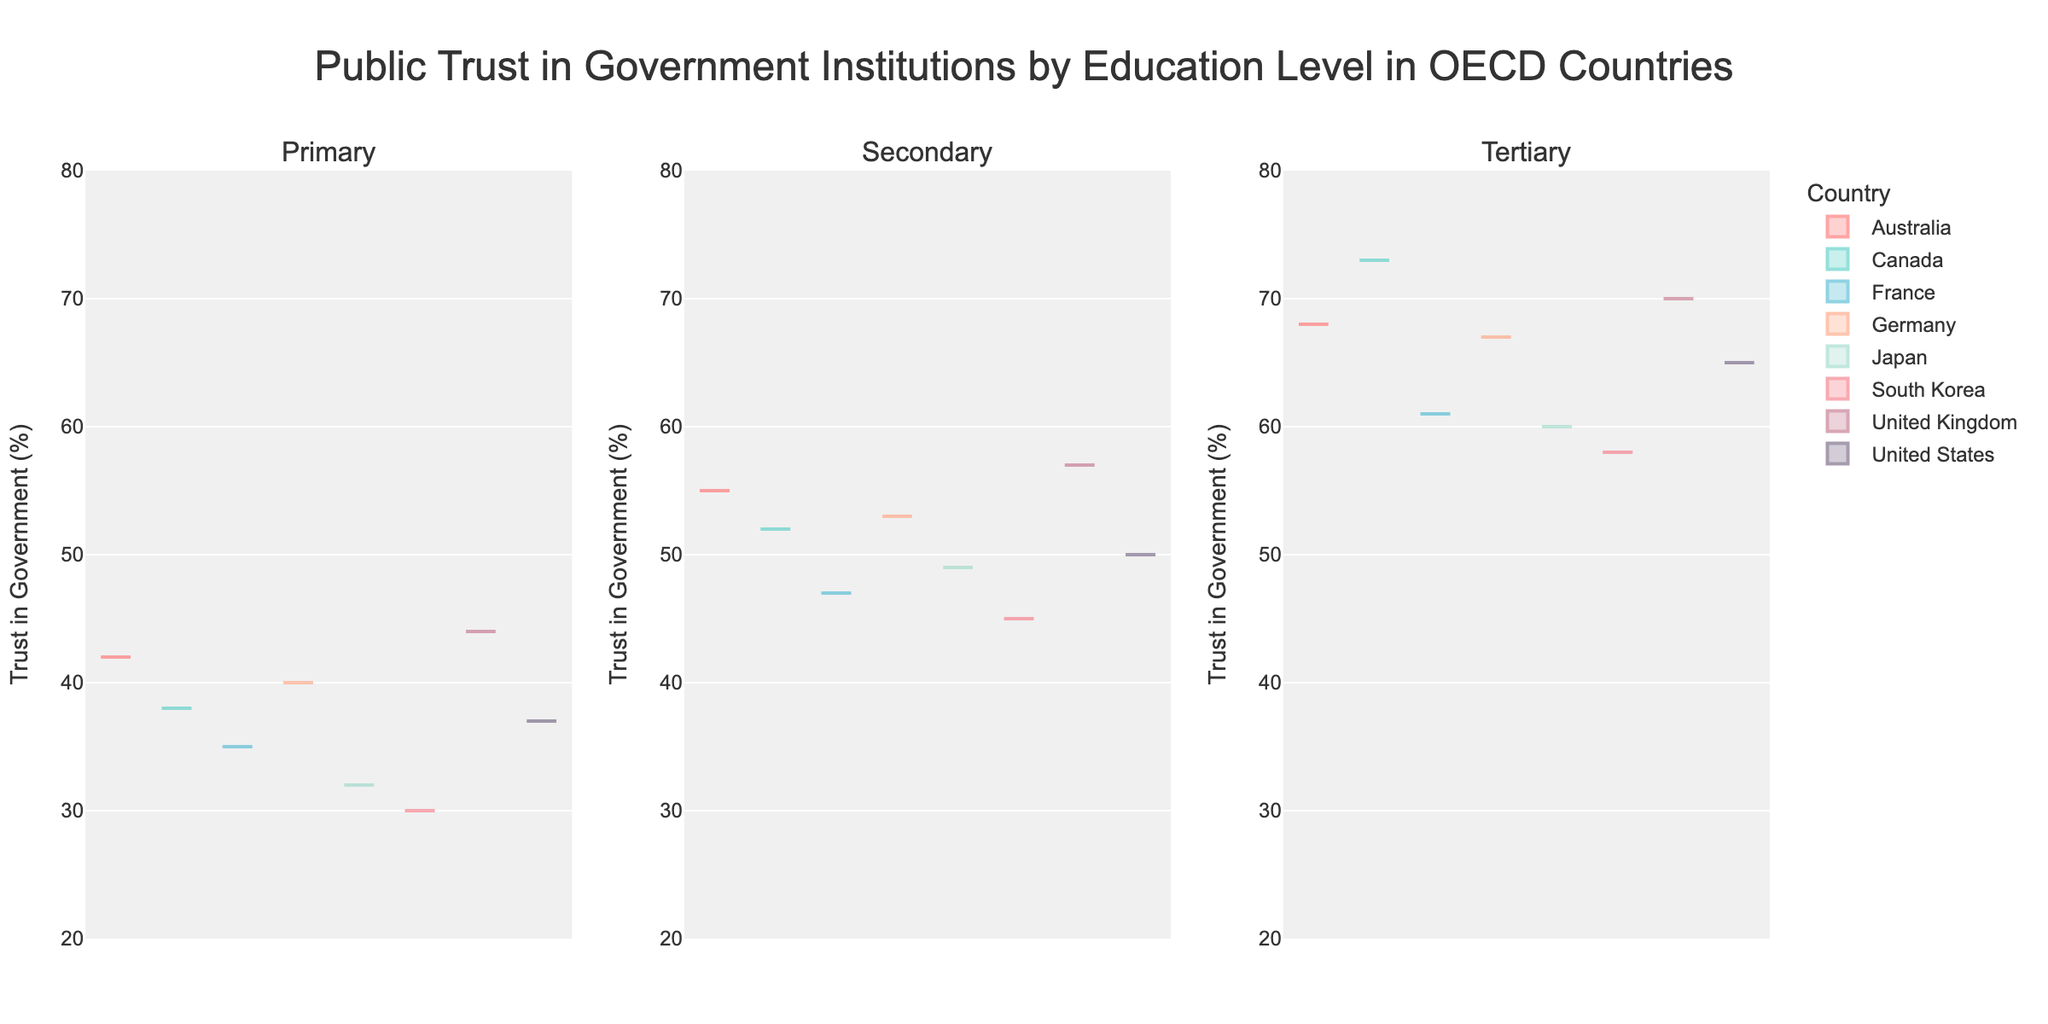what is the title of the plot? The title is placed at the top center of the plot, which is a standard location for the title in most figures. It gives a general idea of the content of the plot.
Answer: Public Trust in Government Institutions by Education Level in OECD Countries How many subplots are there in the figure? There are three columns of subplots arranged in a single row, each corresponding to different education levels as indicated by their subplot titles.
Answer: Three What is the range of the y-axis? Examining the y-axis of the plot reveals the minimum and maximum values, which help to understand the scale of trust percentages.
Answer: 20 to 80 Which subplot shows the highest trust in government for the 'Tertiary' education level? By comparing the positions of the highest data points in the tertiary subplot, it can be determined which country has the highest trust in government for that education level.
Answer: Canada (73%) Which country shows the lowest trust in government at the 'Primary' education level? Locate the primary subplot and identify the lowest data point to determine the country with the lowest trust for that education level.
Answer: South Korea (30%) What is the average trust in government for Germany across all education levels? Calculate the average by summing up the trust values for Germany across primary (40), secondary (53), and tertiary (67) education levels, then dividing by the number of levels.
Answer: (40 + 53 + 67) / 3 = 160 / 3 = 53.33 Which country shows a higher trust in government at the secondary level, Australia or Japan? Compare the trust values in the secondary subplot for Australia (55) and Japan (49).
Answer: Australia (55%) How do the trust in government levels compare between primary and tertiary education levels in the United States? Compare the trust values for primary (37) and tertiary (65) education levels in the subplots for the United States.
Answer: Primary: 37, Tertiary: 65 Is the variance higher in trust among countries with primary education levels or tertiary education levels? Visually assess the spread of data points in the subplots for primary and tertiary education levels. A wider spread indicates higher variance.
Answer: Primary 